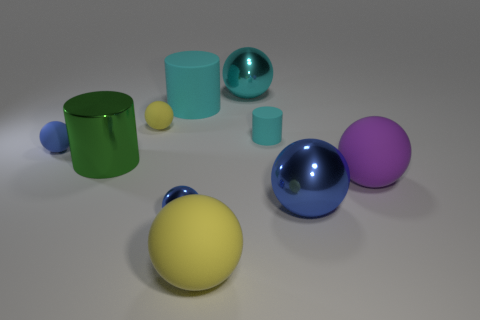There is a small sphere to the right of the yellow rubber thing that is behind the yellow ball that is in front of the tiny blue shiny sphere; what is it made of?
Your answer should be compact. Metal. Does the metal sphere that is on the left side of the cyan shiny object have the same size as the matte thing that is on the left side of the green object?
Make the answer very short. Yes. How many other things are there of the same material as the tiny yellow ball?
Keep it short and to the point. 5. How many metallic things are either large yellow objects or purple spheres?
Make the answer very short. 0. Are there fewer big cyan balls than tiny blue matte cubes?
Give a very brief answer. No. Is the size of the cyan metallic object the same as the matte sphere behind the tiny cyan rubber cylinder?
Your answer should be compact. No. What is the size of the shiny cylinder?
Your answer should be compact. Large. Is the number of tiny matte cylinders in front of the large green metallic object less than the number of big purple metal cylinders?
Your response must be concise. No. Do the green metallic cylinder and the purple thing have the same size?
Keep it short and to the point. Yes. There is a cylinder that is the same material as the cyan sphere; what is its color?
Your answer should be compact. Green. 